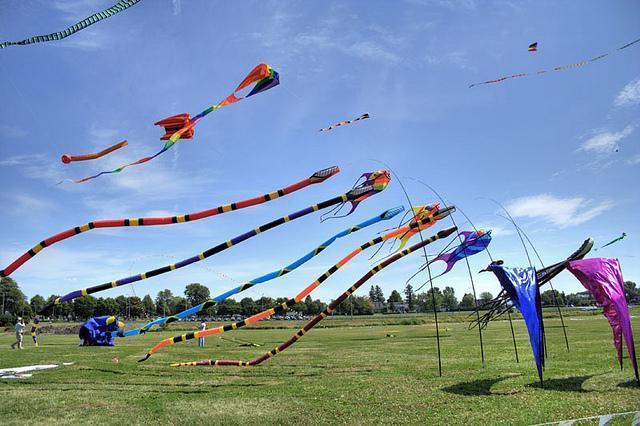How many people are in this picture?
Give a very brief answer. 2. How many kites are there?
Give a very brief answer. 6. 